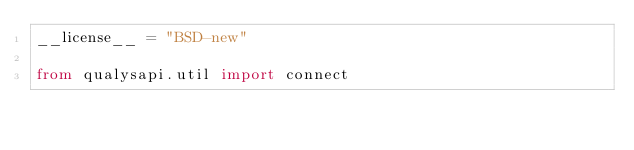Convert code to text. <code><loc_0><loc_0><loc_500><loc_500><_Python_>__license__ = "BSD-new"

from qualysapi.util import connect
</code> 